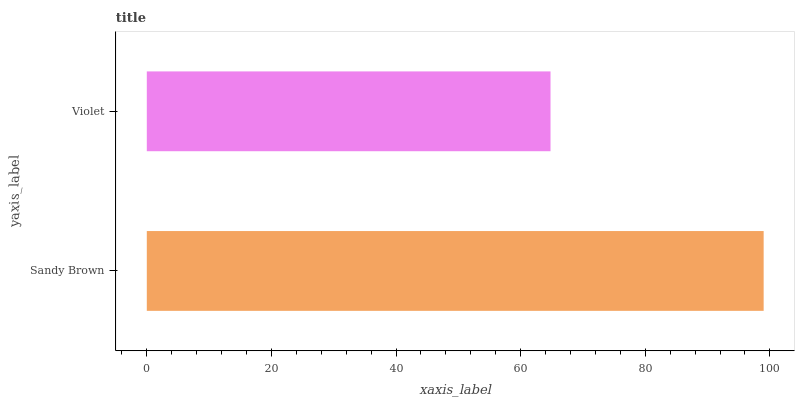Is Violet the minimum?
Answer yes or no. Yes. Is Sandy Brown the maximum?
Answer yes or no. Yes. Is Violet the maximum?
Answer yes or no. No. Is Sandy Brown greater than Violet?
Answer yes or no. Yes. Is Violet less than Sandy Brown?
Answer yes or no. Yes. Is Violet greater than Sandy Brown?
Answer yes or no. No. Is Sandy Brown less than Violet?
Answer yes or no. No. Is Sandy Brown the high median?
Answer yes or no. Yes. Is Violet the low median?
Answer yes or no. Yes. Is Violet the high median?
Answer yes or no. No. Is Sandy Brown the low median?
Answer yes or no. No. 